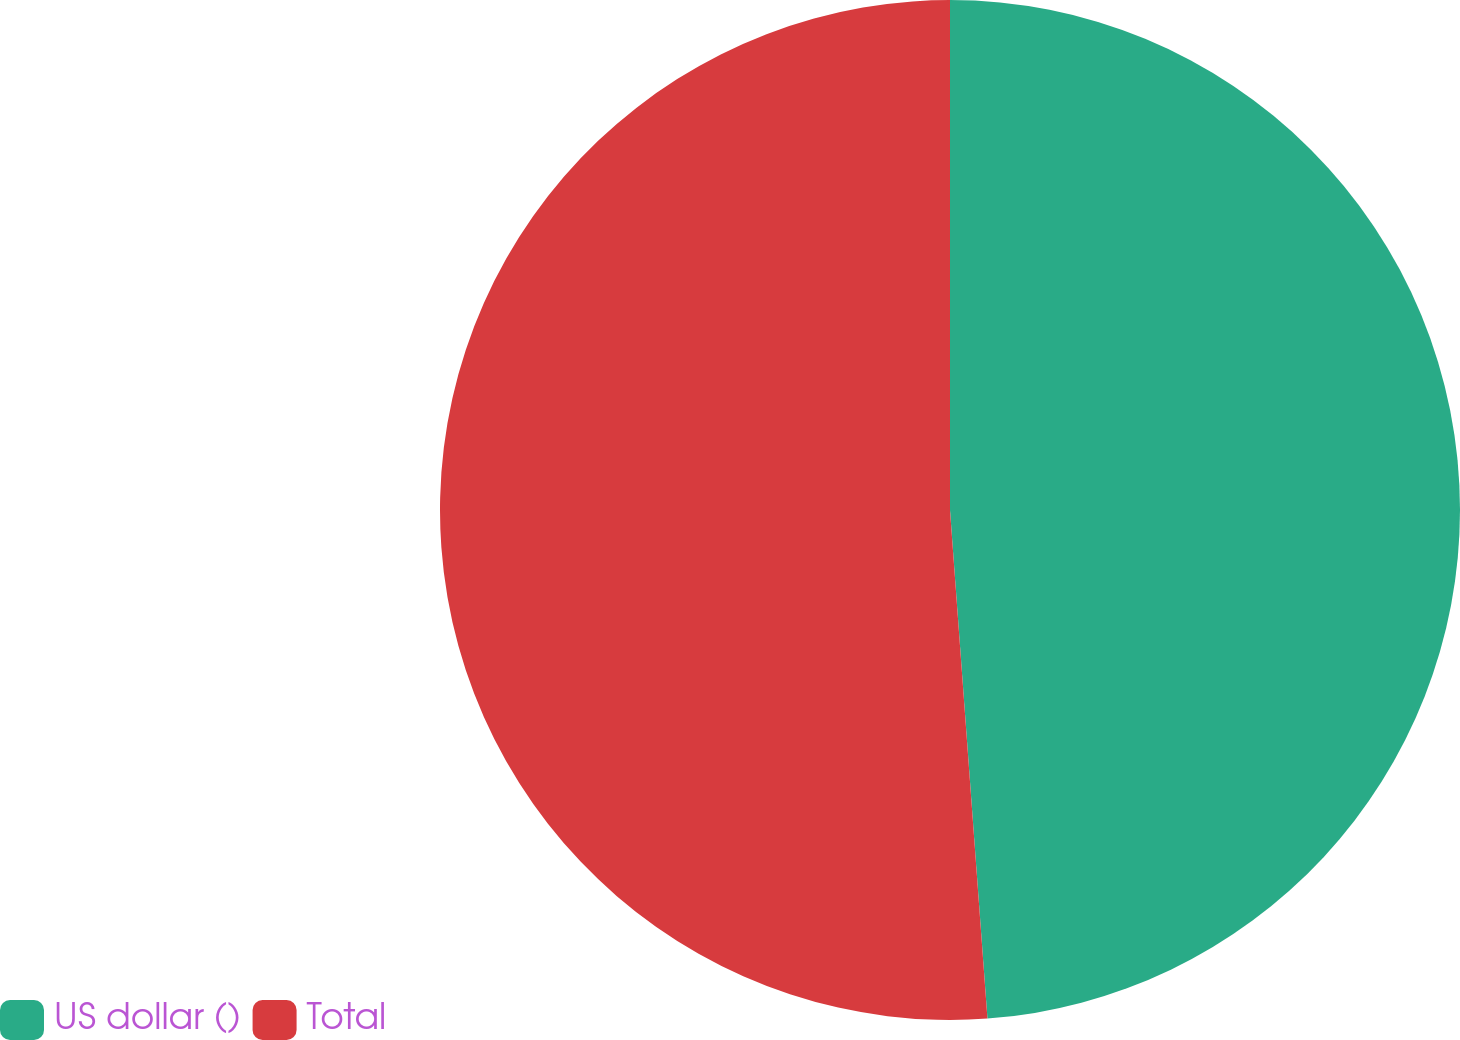Convert chart. <chart><loc_0><loc_0><loc_500><loc_500><pie_chart><fcel>US dollar ()<fcel>Total<nl><fcel>48.83%<fcel>51.17%<nl></chart> 